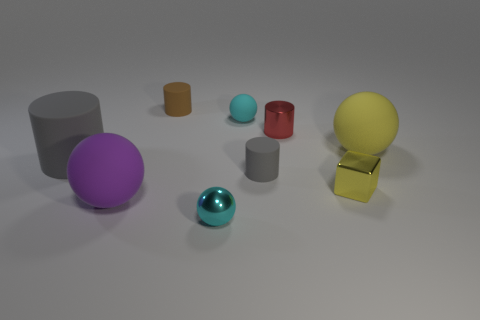Can you point out all the objects that are shades of blue? Certainly, there are three objects with shades of blue in the image: a large cyan ball, a small cyan cylinder, and a tiny cyan matte ball. 